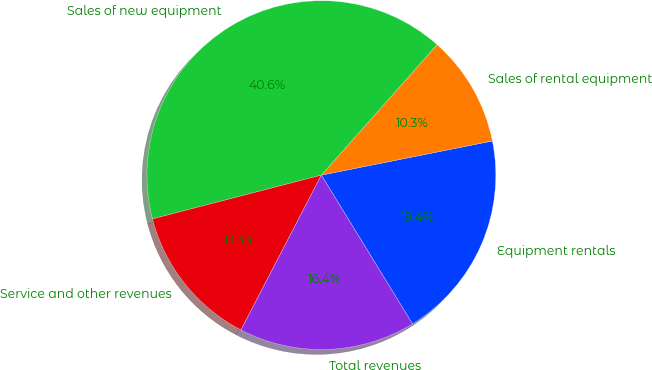Convert chart. <chart><loc_0><loc_0><loc_500><loc_500><pie_chart><fcel>Equipment rentals<fcel>Sales of rental equipment<fcel>Sales of new equipment<fcel>Service and other revenues<fcel>Total revenues<nl><fcel>19.39%<fcel>10.31%<fcel>40.59%<fcel>13.34%<fcel>16.37%<nl></chart> 